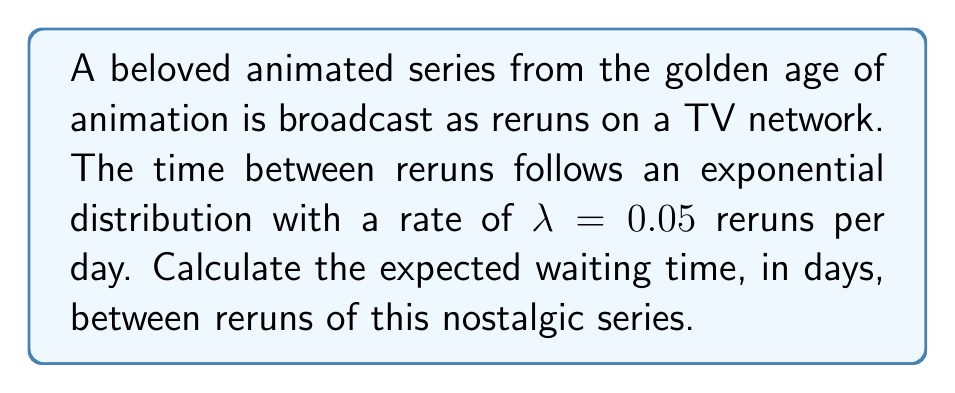Solve this math problem. To solve this problem, we'll use the properties of the exponential distribution:

1. The exponential distribution is commonly used to model the time between events in a Poisson process.

2. For an exponential distribution with rate parameter $\lambda$, the expected value (mean) is given by:

   $$E[X] = \frac{1}{\lambda}$$

3. In this case, $\lambda = 0.05$ reruns per day.

4. Substituting this value into the formula:

   $$E[X] = \frac{1}{0.05}$$

5. Calculating the result:

   $$E[X] = 20$$

Therefore, the expected waiting time between reruns is 20 days.
Answer: 20 days 